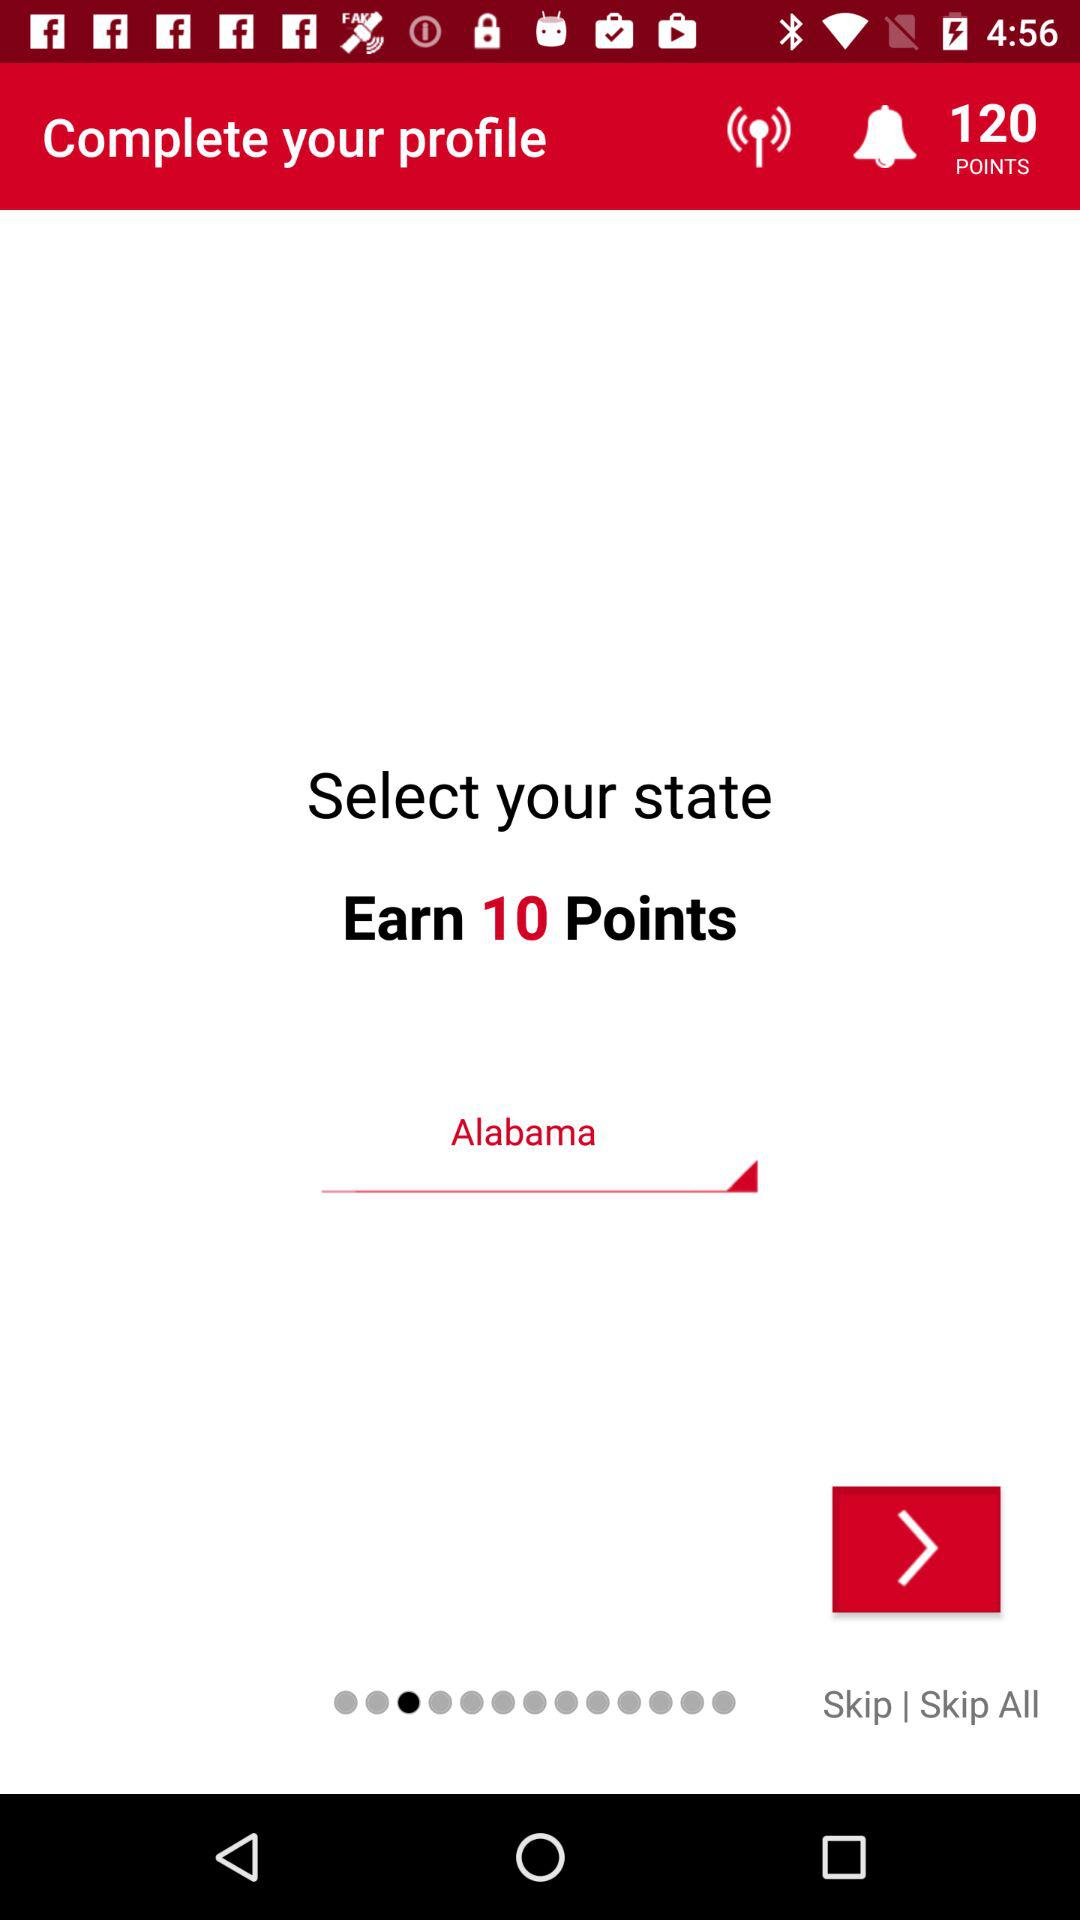How many points are earned while selecting a state? While selecting a state, 10 points are earned. 